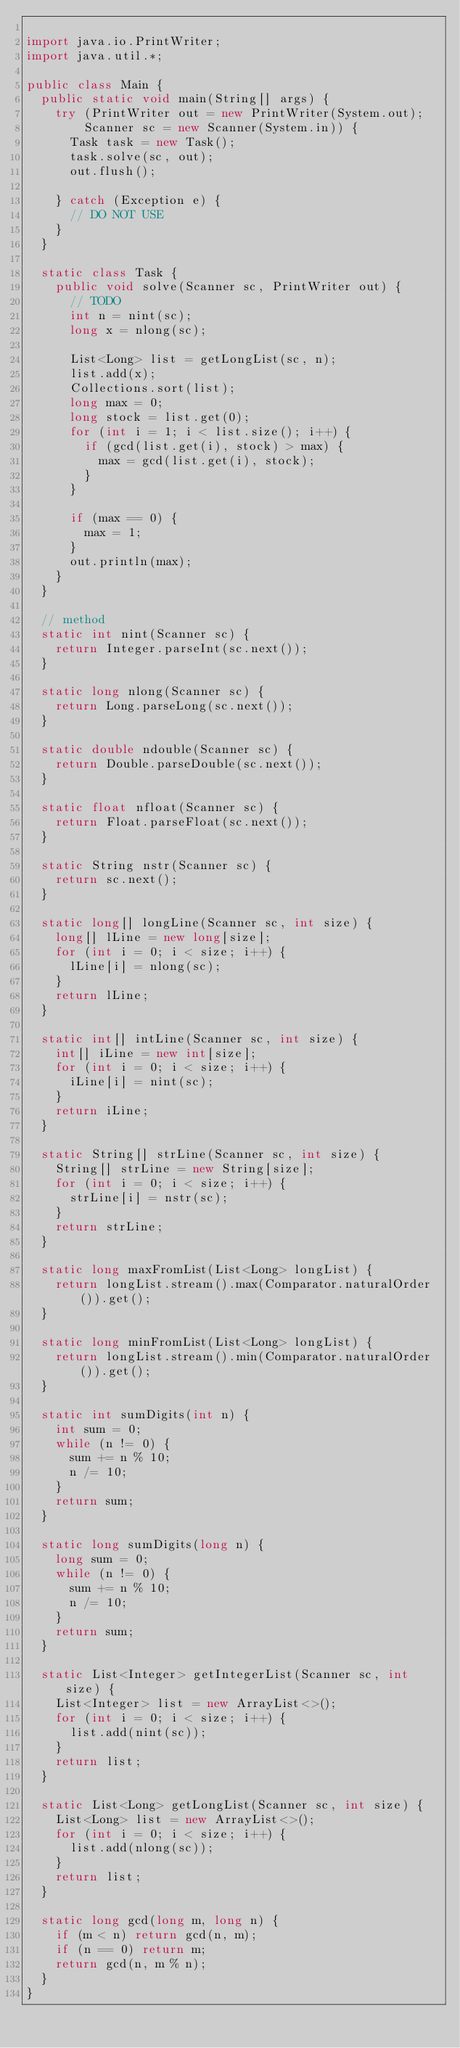<code> <loc_0><loc_0><loc_500><loc_500><_Java_>
import java.io.PrintWriter;
import java.util.*;

public class Main {
  public static void main(String[] args) {
    try (PrintWriter out = new PrintWriter(System.out);
        Scanner sc = new Scanner(System.in)) {
      Task task = new Task();
      task.solve(sc, out);
      out.flush();

    } catch (Exception e) {
      // DO NOT USE
    }
  }

  static class Task {
    public void solve(Scanner sc, PrintWriter out) {
      // TODO
      int n = nint(sc);
      long x = nlong(sc);

      List<Long> list = getLongList(sc, n);
      list.add(x);
      Collections.sort(list);
      long max = 0;
      long stock = list.get(0);
      for (int i = 1; i < list.size(); i++) {
        if (gcd(list.get(i), stock) > max) {
          max = gcd(list.get(i), stock);
        }
      }

      if (max == 0) {
        max = 1;
      }
      out.println(max);
    }
  }

  // method
  static int nint(Scanner sc) {
    return Integer.parseInt(sc.next());
  }

  static long nlong(Scanner sc) {
    return Long.parseLong(sc.next());
  }

  static double ndouble(Scanner sc) {
    return Double.parseDouble(sc.next());
  }

  static float nfloat(Scanner sc) {
    return Float.parseFloat(sc.next());
  }

  static String nstr(Scanner sc) {
    return sc.next();
  }

  static long[] longLine(Scanner sc, int size) {
    long[] lLine = new long[size];
    for (int i = 0; i < size; i++) {
      lLine[i] = nlong(sc);
    }
    return lLine;
  }

  static int[] intLine(Scanner sc, int size) {
    int[] iLine = new int[size];
    for (int i = 0; i < size; i++) {
      iLine[i] = nint(sc);
    }
    return iLine;
  }

  static String[] strLine(Scanner sc, int size) {
    String[] strLine = new String[size];
    for (int i = 0; i < size; i++) {
      strLine[i] = nstr(sc);
    }
    return strLine;
  }

  static long maxFromList(List<Long> longList) {
    return longList.stream().max(Comparator.naturalOrder()).get();
  }

  static long minFromList(List<Long> longList) {
    return longList.stream().min(Comparator.naturalOrder()).get();
  }

  static int sumDigits(int n) {
    int sum = 0;
    while (n != 0) {
      sum += n % 10;
      n /= 10;
    }
    return sum;
  }

  static long sumDigits(long n) {
    long sum = 0;
    while (n != 0) {
      sum += n % 10;
      n /= 10;
    }
    return sum;
  }

  static List<Integer> getIntegerList(Scanner sc, int size) {
    List<Integer> list = new ArrayList<>();
    for (int i = 0; i < size; i++) {
      list.add(nint(sc));
    }
    return list;
  }

  static List<Long> getLongList(Scanner sc, int size) {
    List<Long> list = new ArrayList<>();
    for (int i = 0; i < size; i++) {
      list.add(nlong(sc));
    }
    return list;
  }

  static long gcd(long m, long n) {
    if (m < n) return gcd(n, m);
    if (n == 0) return m;
    return gcd(n, m % n);
  }
}
</code> 